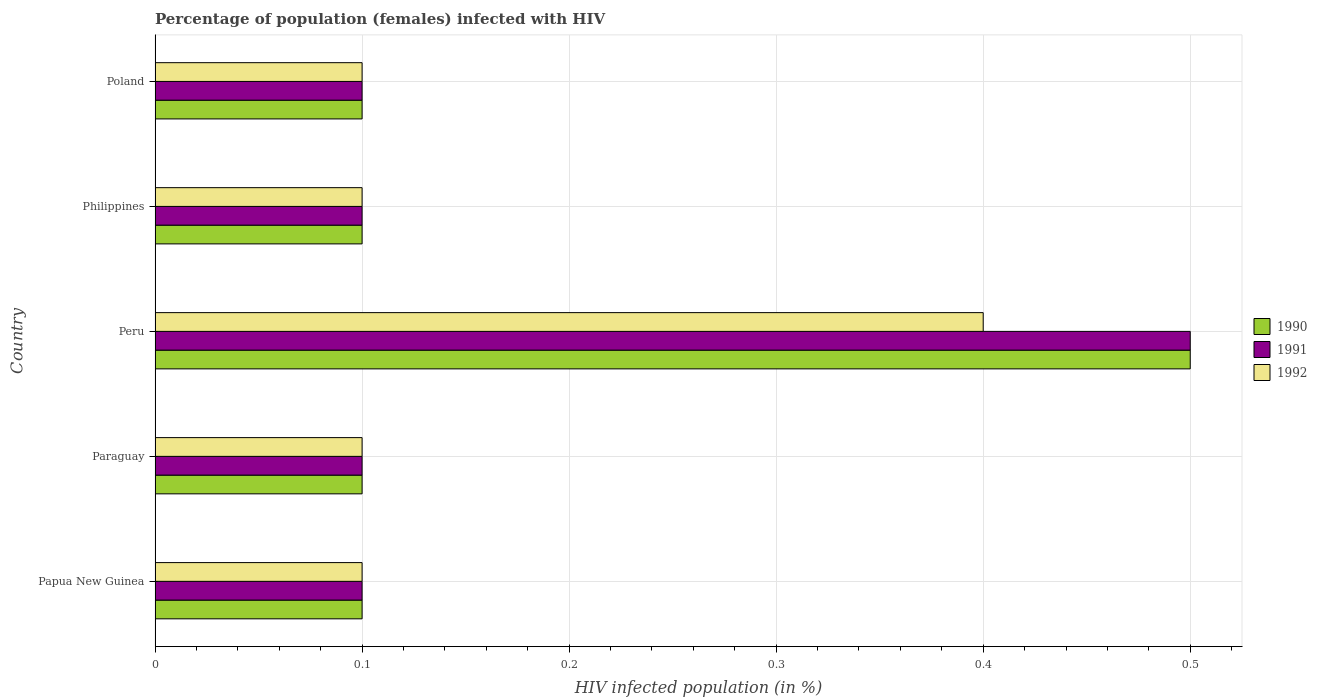How many different coloured bars are there?
Your answer should be compact. 3. How many bars are there on the 5th tick from the top?
Your answer should be very brief. 3. In how many cases, is the number of bars for a given country not equal to the number of legend labels?
Make the answer very short. 0. What is the percentage of HIV infected female population in 1992 in Paraguay?
Your answer should be very brief. 0.1. In which country was the percentage of HIV infected female population in 1992 maximum?
Provide a succinct answer. Peru. In which country was the percentage of HIV infected female population in 1991 minimum?
Ensure brevity in your answer.  Papua New Guinea. What is the total percentage of HIV infected female population in 1990 in the graph?
Your answer should be very brief. 0.9. What is the average percentage of HIV infected female population in 1992 per country?
Your answer should be compact. 0.16. In how many countries, is the percentage of HIV infected female population in 1992 greater than 0.22 %?
Offer a terse response. 1. What is the ratio of the percentage of HIV infected female population in 1990 in Papua New Guinea to that in Philippines?
Make the answer very short. 1. Is the percentage of HIV infected female population in 1990 in Papua New Guinea less than that in Peru?
Your response must be concise. Yes. Is the difference between the percentage of HIV infected female population in 1990 in Papua New Guinea and Paraguay greater than the difference between the percentage of HIV infected female population in 1991 in Papua New Guinea and Paraguay?
Provide a short and direct response. No. What is the difference between the highest and the second highest percentage of HIV infected female population in 1990?
Provide a short and direct response. 0.4. What is the difference between the highest and the lowest percentage of HIV infected female population in 1992?
Provide a short and direct response. 0.3. In how many countries, is the percentage of HIV infected female population in 1992 greater than the average percentage of HIV infected female population in 1992 taken over all countries?
Ensure brevity in your answer.  1. What does the 3rd bar from the top in Peru represents?
Offer a terse response. 1990. What does the 3rd bar from the bottom in Papua New Guinea represents?
Your answer should be very brief. 1992. Is it the case that in every country, the sum of the percentage of HIV infected female population in 1992 and percentage of HIV infected female population in 1991 is greater than the percentage of HIV infected female population in 1990?
Provide a succinct answer. Yes. How many bars are there?
Ensure brevity in your answer.  15. What is the difference between two consecutive major ticks on the X-axis?
Your answer should be compact. 0.1. Does the graph contain any zero values?
Offer a very short reply. No. Does the graph contain grids?
Your response must be concise. Yes. Where does the legend appear in the graph?
Give a very brief answer. Center right. How many legend labels are there?
Make the answer very short. 3. How are the legend labels stacked?
Your answer should be very brief. Vertical. What is the title of the graph?
Provide a succinct answer. Percentage of population (females) infected with HIV. Does "2007" appear as one of the legend labels in the graph?
Offer a very short reply. No. What is the label or title of the X-axis?
Provide a succinct answer. HIV infected population (in %). What is the HIV infected population (in %) in 1990 in Papua New Guinea?
Give a very brief answer. 0.1. What is the HIV infected population (in %) of 1991 in Papua New Guinea?
Make the answer very short. 0.1. What is the HIV infected population (in %) of 1991 in Paraguay?
Make the answer very short. 0.1. What is the HIV infected population (in %) of 1992 in Paraguay?
Provide a short and direct response. 0.1. What is the HIV infected population (in %) in 1992 in Peru?
Offer a terse response. 0.4. What is the HIV infected population (in %) in 1990 in Poland?
Make the answer very short. 0.1. What is the HIV infected population (in %) in 1991 in Poland?
Give a very brief answer. 0.1. What is the HIV infected population (in %) in 1992 in Poland?
Offer a terse response. 0.1. Across all countries, what is the maximum HIV infected population (in %) in 1990?
Offer a very short reply. 0.5. Across all countries, what is the maximum HIV infected population (in %) in 1991?
Make the answer very short. 0.5. Across all countries, what is the maximum HIV infected population (in %) of 1992?
Provide a succinct answer. 0.4. Across all countries, what is the minimum HIV infected population (in %) in 1990?
Ensure brevity in your answer.  0.1. Across all countries, what is the minimum HIV infected population (in %) in 1991?
Your answer should be very brief. 0.1. What is the total HIV infected population (in %) in 1990 in the graph?
Provide a succinct answer. 0.9. What is the total HIV infected population (in %) of 1992 in the graph?
Ensure brevity in your answer.  0.8. What is the difference between the HIV infected population (in %) in 1990 in Papua New Guinea and that in Paraguay?
Make the answer very short. 0. What is the difference between the HIV infected population (in %) of 1991 in Papua New Guinea and that in Paraguay?
Keep it short and to the point. 0. What is the difference between the HIV infected population (in %) in 1992 in Papua New Guinea and that in Peru?
Provide a succinct answer. -0.3. What is the difference between the HIV infected population (in %) in 1990 in Papua New Guinea and that in Philippines?
Ensure brevity in your answer.  0. What is the difference between the HIV infected population (in %) of 1991 in Papua New Guinea and that in Philippines?
Your answer should be very brief. 0. What is the difference between the HIV infected population (in %) in 1992 in Papua New Guinea and that in Philippines?
Make the answer very short. 0. What is the difference between the HIV infected population (in %) in 1991 in Papua New Guinea and that in Poland?
Your response must be concise. 0. What is the difference between the HIV infected population (in %) of 1990 in Paraguay and that in Peru?
Offer a terse response. -0.4. What is the difference between the HIV infected population (in %) in 1991 in Paraguay and that in Peru?
Keep it short and to the point. -0.4. What is the difference between the HIV infected population (in %) in 1990 in Paraguay and that in Philippines?
Keep it short and to the point. 0. What is the difference between the HIV infected population (in %) of 1991 in Paraguay and that in Philippines?
Your answer should be compact. 0. What is the difference between the HIV infected population (in %) in 1990 in Peru and that in Philippines?
Your answer should be compact. 0.4. What is the difference between the HIV infected population (in %) in 1991 in Peru and that in Philippines?
Keep it short and to the point. 0.4. What is the difference between the HIV infected population (in %) of 1992 in Peru and that in Philippines?
Your response must be concise. 0.3. What is the difference between the HIV infected population (in %) of 1990 in Peru and that in Poland?
Provide a succinct answer. 0.4. What is the difference between the HIV infected population (in %) in 1991 in Peru and that in Poland?
Offer a very short reply. 0.4. What is the difference between the HIV infected population (in %) in 1992 in Peru and that in Poland?
Your answer should be compact. 0.3. What is the difference between the HIV infected population (in %) in 1990 in Philippines and that in Poland?
Provide a succinct answer. 0. What is the difference between the HIV infected population (in %) of 1990 in Papua New Guinea and the HIV infected population (in %) of 1992 in Peru?
Offer a very short reply. -0.3. What is the difference between the HIV infected population (in %) of 1990 in Papua New Guinea and the HIV infected population (in %) of 1991 in Philippines?
Your answer should be compact. 0. What is the difference between the HIV infected population (in %) in 1991 in Papua New Guinea and the HIV infected population (in %) in 1992 in Philippines?
Keep it short and to the point. 0. What is the difference between the HIV infected population (in %) of 1990 in Papua New Guinea and the HIV infected population (in %) of 1991 in Poland?
Provide a succinct answer. 0. What is the difference between the HIV infected population (in %) in 1990 in Paraguay and the HIV infected population (in %) in 1991 in Peru?
Ensure brevity in your answer.  -0.4. What is the difference between the HIV infected population (in %) in 1990 in Paraguay and the HIV infected population (in %) in 1992 in Peru?
Ensure brevity in your answer.  -0.3. What is the difference between the HIV infected population (in %) in 1991 in Paraguay and the HIV infected population (in %) in 1992 in Peru?
Your answer should be compact. -0.3. What is the difference between the HIV infected population (in %) of 1990 in Paraguay and the HIV infected population (in %) of 1991 in Philippines?
Your answer should be very brief. 0. What is the difference between the HIV infected population (in %) in 1991 in Paraguay and the HIV infected population (in %) in 1992 in Philippines?
Your answer should be very brief. 0. What is the difference between the HIV infected population (in %) in 1991 in Paraguay and the HIV infected population (in %) in 1992 in Poland?
Ensure brevity in your answer.  0. What is the difference between the HIV infected population (in %) of 1990 in Peru and the HIV infected population (in %) of 1991 in Philippines?
Your answer should be compact. 0.4. What is the difference between the HIV infected population (in %) in 1990 in Peru and the HIV infected population (in %) in 1992 in Poland?
Your response must be concise. 0.4. What is the difference between the HIV infected population (in %) of 1990 in Philippines and the HIV infected population (in %) of 1992 in Poland?
Your answer should be very brief. 0. What is the average HIV infected population (in %) in 1990 per country?
Offer a terse response. 0.18. What is the average HIV infected population (in %) of 1991 per country?
Your answer should be compact. 0.18. What is the average HIV infected population (in %) in 1992 per country?
Provide a succinct answer. 0.16. What is the difference between the HIV infected population (in %) in 1990 and HIV infected population (in %) in 1991 in Papua New Guinea?
Your answer should be compact. 0. What is the difference between the HIV infected population (in %) in 1990 and HIV infected population (in %) in 1992 in Papua New Guinea?
Your answer should be very brief. 0. What is the difference between the HIV infected population (in %) in 1991 and HIV infected population (in %) in 1992 in Papua New Guinea?
Make the answer very short. 0. What is the difference between the HIV infected population (in %) of 1990 and HIV infected population (in %) of 1992 in Paraguay?
Ensure brevity in your answer.  0. What is the difference between the HIV infected population (in %) of 1990 and HIV infected population (in %) of 1991 in Philippines?
Provide a succinct answer. 0. What is the difference between the HIV infected population (in %) of 1990 and HIV infected population (in %) of 1992 in Philippines?
Keep it short and to the point. 0. What is the difference between the HIV infected population (in %) of 1990 and HIV infected population (in %) of 1991 in Poland?
Provide a succinct answer. 0. What is the ratio of the HIV infected population (in %) of 1992 in Papua New Guinea to that in Paraguay?
Your answer should be compact. 1. What is the ratio of the HIV infected population (in %) in 1990 in Papua New Guinea to that in Peru?
Make the answer very short. 0.2. What is the ratio of the HIV infected population (in %) of 1992 in Papua New Guinea to that in Peru?
Provide a succinct answer. 0.25. What is the ratio of the HIV infected population (in %) of 1991 in Papua New Guinea to that in Philippines?
Ensure brevity in your answer.  1. What is the ratio of the HIV infected population (in %) in 1992 in Papua New Guinea to that in Philippines?
Offer a very short reply. 1. What is the ratio of the HIV infected population (in %) in 1991 in Papua New Guinea to that in Poland?
Your answer should be very brief. 1. What is the ratio of the HIV infected population (in %) in 1991 in Paraguay to that in Peru?
Your answer should be compact. 0.2. What is the ratio of the HIV infected population (in %) in 1992 in Paraguay to that in Peru?
Your answer should be compact. 0.25. What is the ratio of the HIV infected population (in %) in 1990 in Paraguay to that in Philippines?
Provide a short and direct response. 1. What is the ratio of the HIV infected population (in %) in 1992 in Paraguay to that in Philippines?
Offer a terse response. 1. What is the ratio of the HIV infected population (in %) of 1991 in Paraguay to that in Poland?
Your answer should be very brief. 1. What is the ratio of the HIV infected population (in %) in 1992 in Paraguay to that in Poland?
Your answer should be compact. 1. What is the ratio of the HIV infected population (in %) of 1991 in Peru to that in Philippines?
Give a very brief answer. 5. What is the ratio of the HIV infected population (in %) of 1992 in Peru to that in Poland?
Provide a short and direct response. 4. What is the ratio of the HIV infected population (in %) of 1991 in Philippines to that in Poland?
Keep it short and to the point. 1. What is the ratio of the HIV infected population (in %) of 1992 in Philippines to that in Poland?
Give a very brief answer. 1. What is the difference between the highest and the second highest HIV infected population (in %) in 1992?
Your response must be concise. 0.3. What is the difference between the highest and the lowest HIV infected population (in %) in 1990?
Your answer should be compact. 0.4. What is the difference between the highest and the lowest HIV infected population (in %) of 1991?
Provide a short and direct response. 0.4. 